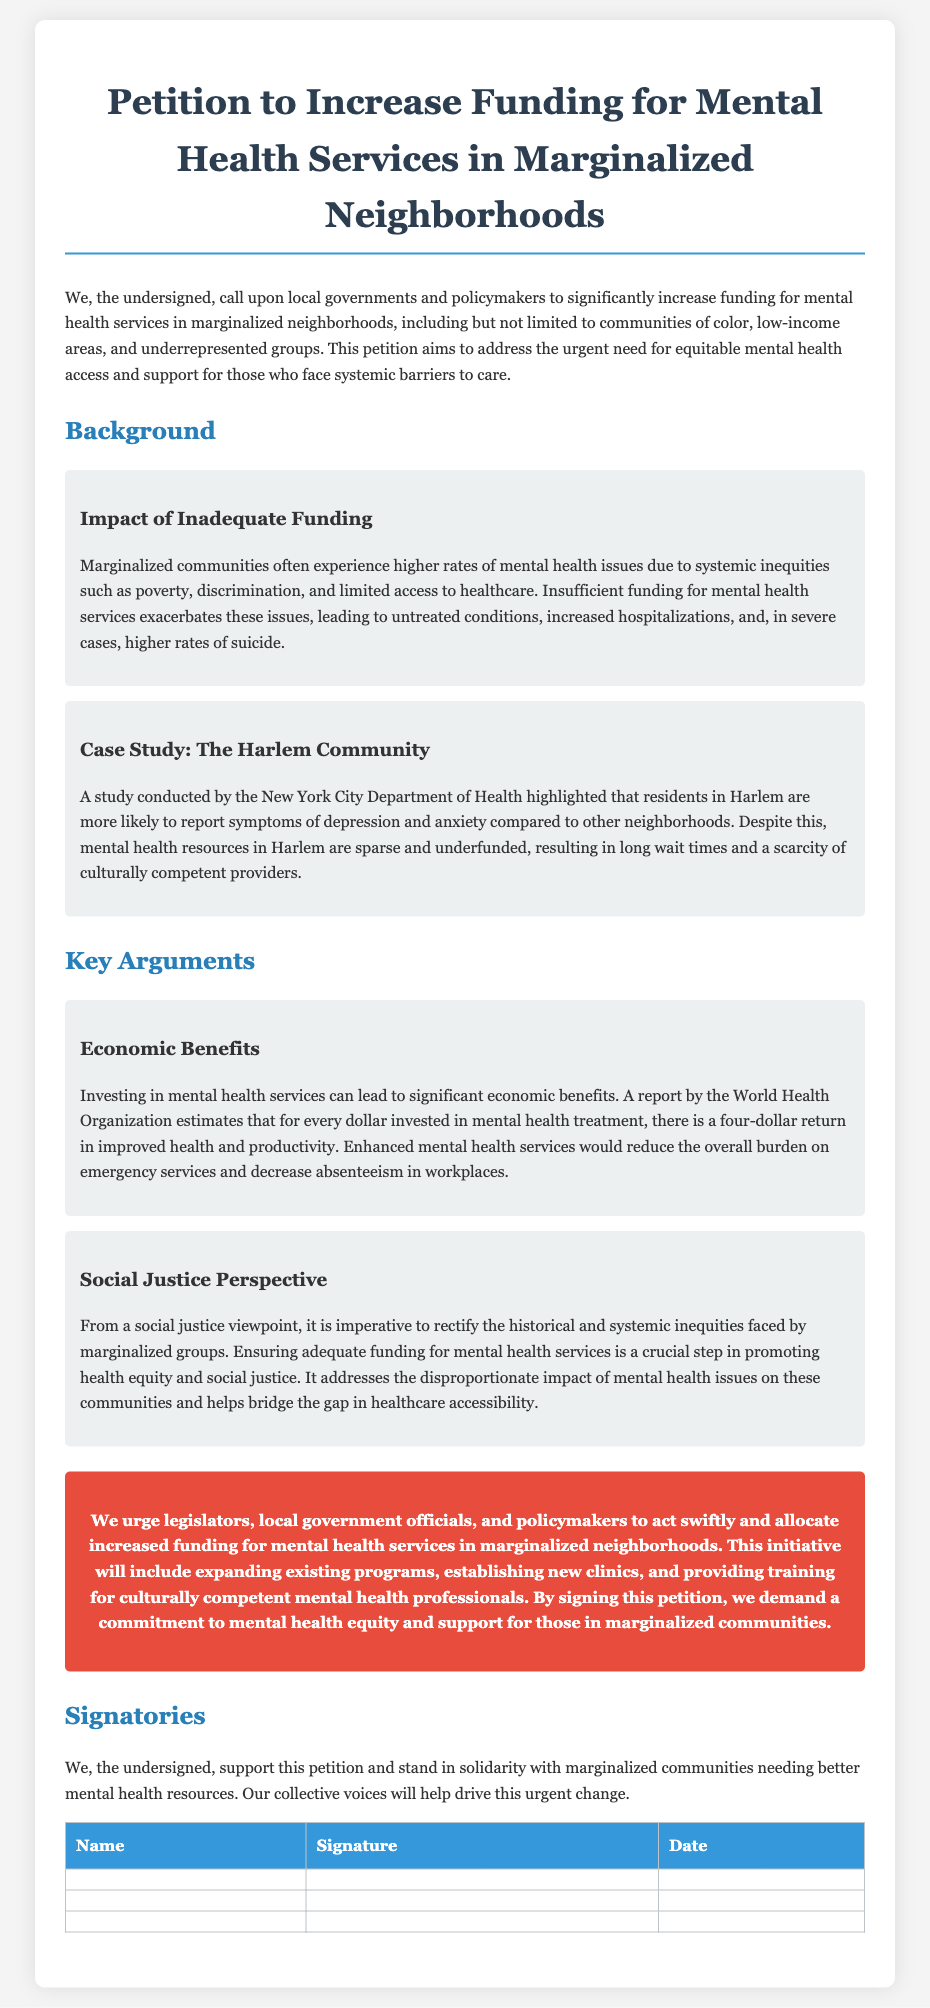What is the title of the petition? The title of the petition is prominently displayed at the top of the document.
Answer: Petition to Increase Funding for Mental Health Services in Marginalized Neighborhoods What specific communities are mentioned in the introduction? The introduction explicitly mentions marginalized communities, including communities of color and low-income areas.
Answer: Communities of color, low-income areas Which department conducted a study on the Harlem community? The specific local department that conducted the study is mentioned in the background section of the document.
Answer: New York City Department of Health What is the estimated return on investment for mental health treatment according to the World Health Organization? The document states an economic benefit for every dollar invested in mental health treatment.
Answer: Four dollars What does the social justice perspective argue regarding mental health funding? The argument emphasizes addressing historical and systemic inequities faced by marginalized groups.
Answer: Health equity and social justice What type of mental health services does the petition urge to expand? The petition specifies expanding existing programs and establishing new clinics in the call to action.
Answer: Existing programs and new clinics Who is the target audience of this petition? The petition aims to compel a specific group to take action regarding mental health funding.
Answer: Legislators, local government officials, policymakers What does the last section of the document focus on? The last section highlights the people who support the petition and the cause it represents.
Answer: Signatories 